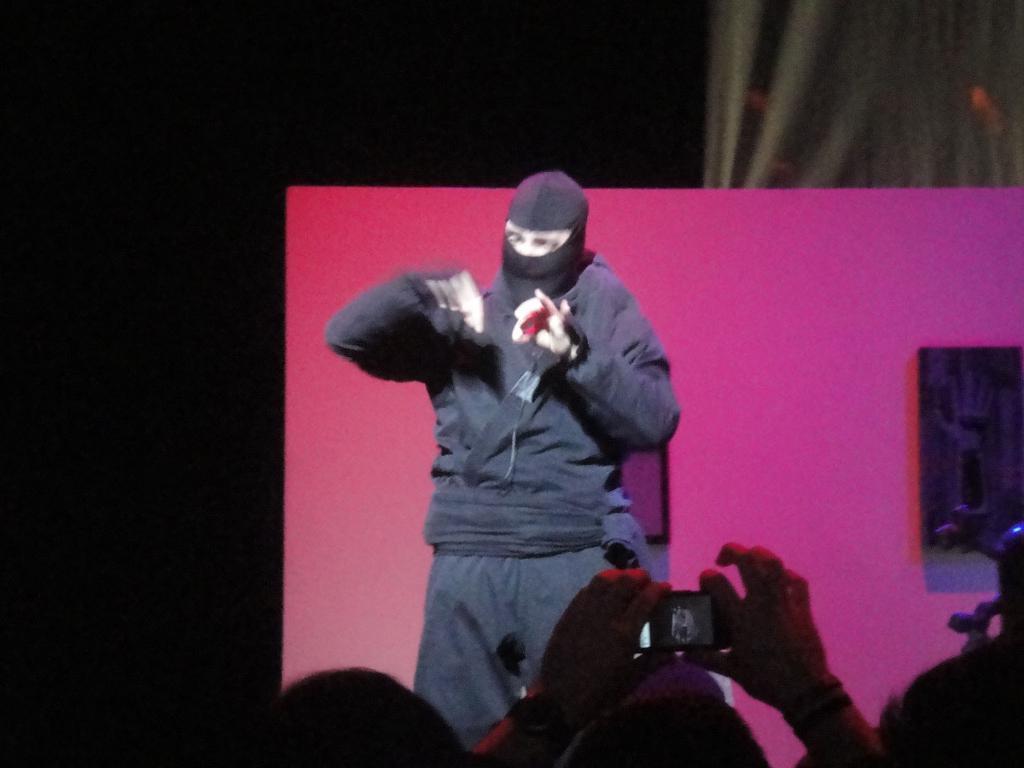Please provide a concise description of this image. Here we can see a person and there is a board. There are few persons. Here we can see a person holding a mobile. There is a cloth and dark background. 